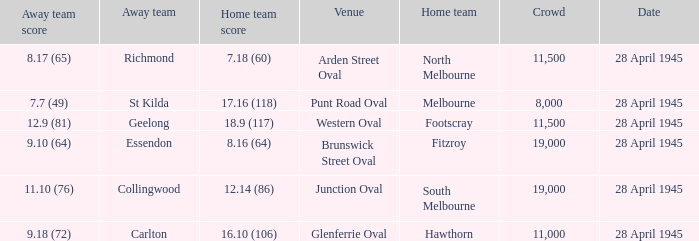What home team has an Away team of richmond? North Melbourne. 